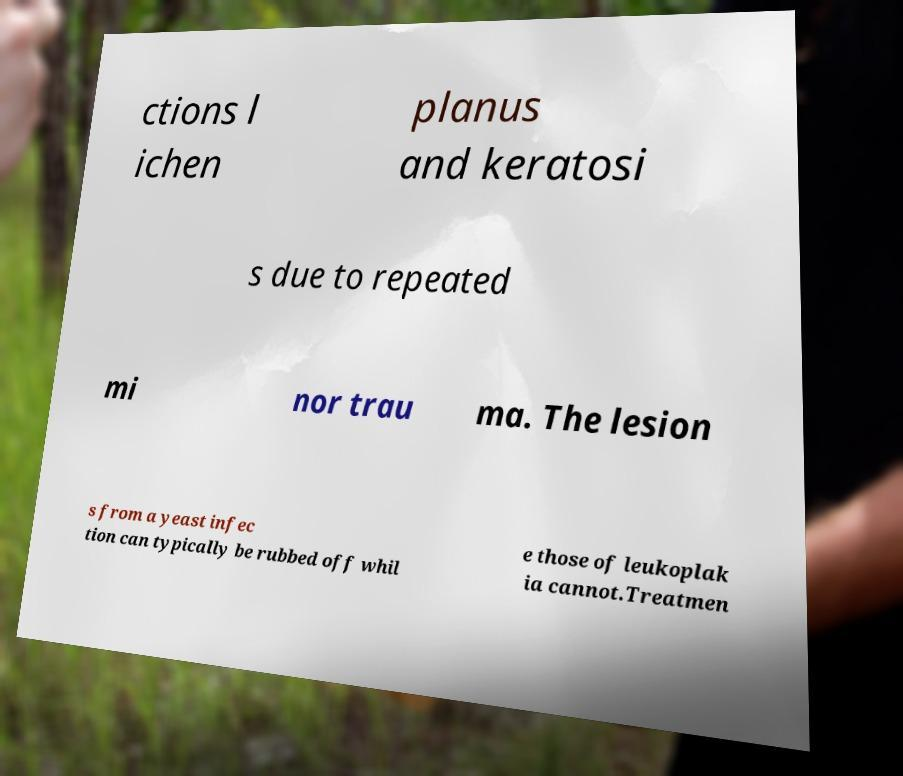What messages or text are displayed in this image? I need them in a readable, typed format. ctions l ichen planus and keratosi s due to repeated mi nor trau ma. The lesion s from a yeast infec tion can typically be rubbed off whil e those of leukoplak ia cannot.Treatmen 